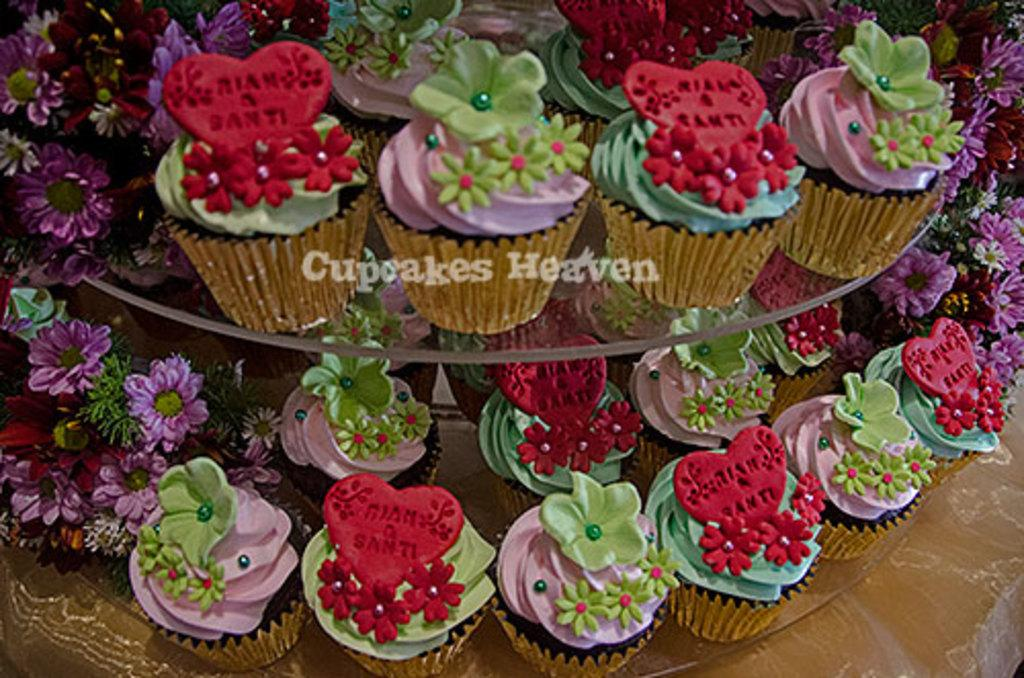What type of dessert can be seen in the image? There are cupcakes placed in a stand in the image. What other objects or elements are present in the image? There are flowers in the image. What type of car is parked next to the cupcakes in the image? There is no car present in the image; it only features cupcakes and flowers. 